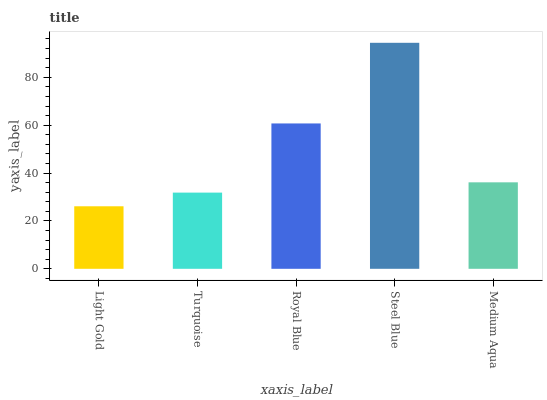Is Light Gold the minimum?
Answer yes or no. Yes. Is Steel Blue the maximum?
Answer yes or no. Yes. Is Turquoise the minimum?
Answer yes or no. No. Is Turquoise the maximum?
Answer yes or no. No. Is Turquoise greater than Light Gold?
Answer yes or no. Yes. Is Light Gold less than Turquoise?
Answer yes or no. Yes. Is Light Gold greater than Turquoise?
Answer yes or no. No. Is Turquoise less than Light Gold?
Answer yes or no. No. Is Medium Aqua the high median?
Answer yes or no. Yes. Is Medium Aqua the low median?
Answer yes or no. Yes. Is Royal Blue the high median?
Answer yes or no. No. Is Steel Blue the low median?
Answer yes or no. No. 